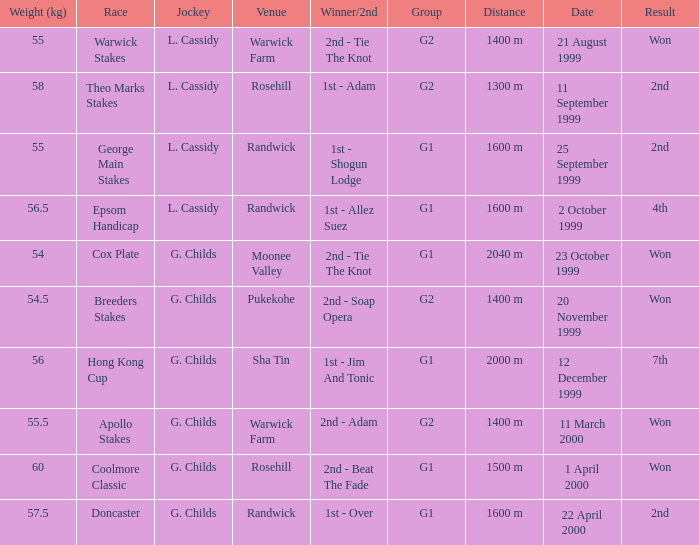How man teams had a total weight of 57.5? 1.0. Give me the full table as a dictionary. {'header': ['Weight (kg)', 'Race', 'Jockey', 'Venue', 'Winner/2nd', 'Group', 'Distance', 'Date', 'Result'], 'rows': [['55', 'Warwick Stakes', 'L. Cassidy', 'Warwick Farm', '2nd - Tie The Knot', 'G2', '1400 m', '21 August 1999', 'Won'], ['58', 'Theo Marks Stakes', 'L. Cassidy', 'Rosehill', '1st - Adam', 'G2', '1300 m', '11 September 1999', '2nd'], ['55', 'George Main Stakes', 'L. Cassidy', 'Randwick', '1st - Shogun Lodge', 'G1', '1600 m', '25 September 1999', '2nd'], ['56.5', 'Epsom Handicap', 'L. Cassidy', 'Randwick', '1st - Allez Suez', 'G1', '1600 m', '2 October 1999', '4th'], ['54', 'Cox Plate', 'G. Childs', 'Moonee Valley', '2nd - Tie The Knot', 'G1', '2040 m', '23 October 1999', 'Won'], ['54.5', 'Breeders Stakes', 'G. Childs', 'Pukekohe', '2nd - Soap Opera', 'G2', '1400 m', '20 November 1999', 'Won'], ['56', 'Hong Kong Cup', 'G. Childs', 'Sha Tin', '1st - Jim And Tonic', 'G1', '2000 m', '12 December 1999', '7th'], ['55.5', 'Apollo Stakes', 'G. Childs', 'Warwick Farm', '2nd - Adam', 'G2', '1400 m', '11 March 2000', 'Won'], ['60', 'Coolmore Classic', 'G. Childs', 'Rosehill', '2nd - Beat The Fade', 'G1', '1500 m', '1 April 2000', 'Won'], ['57.5', 'Doncaster', 'G. Childs', 'Randwick', '1st - Over', 'G1', '1600 m', '22 April 2000', '2nd']]} 